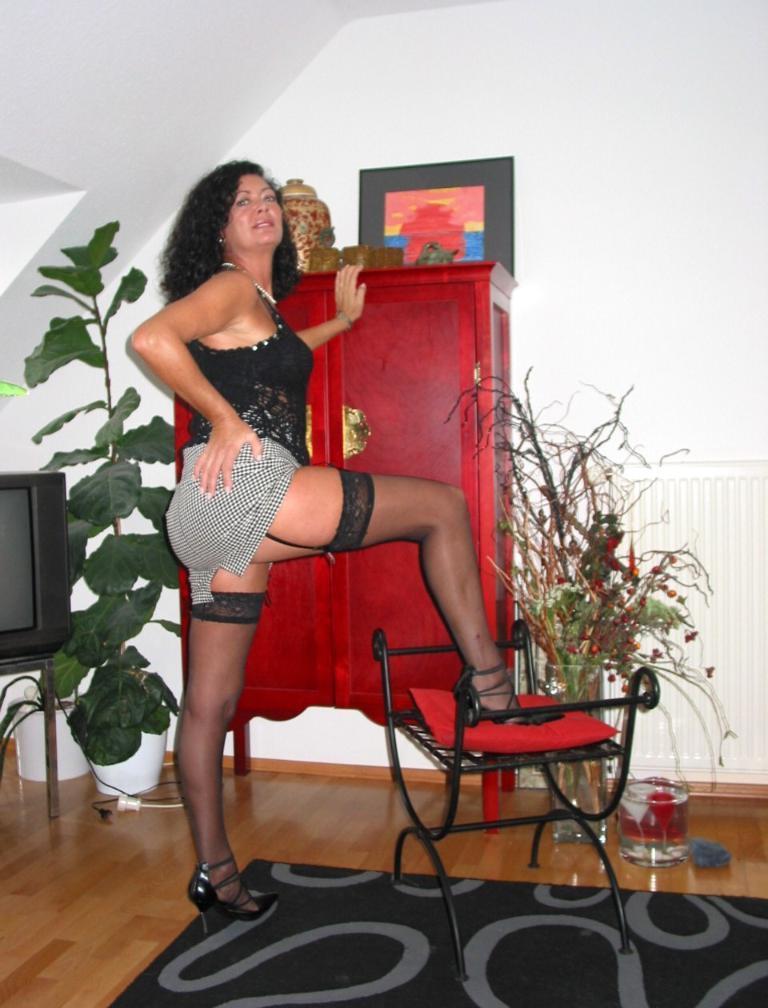Can you describe this image briefly? In this picture we can see a woman kept her leg on a red object. This red object is visible on a stool. We can see a carpet on the floor. There are a few glass objects, houseplants and a television on the left side. We can see a frame and some things on a cupboard. A wall is visible in the background. 